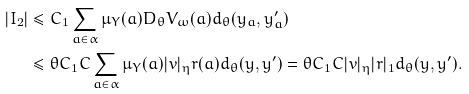<formula> <loc_0><loc_0><loc_500><loc_500>| I _ { 2 } | & \leq C _ { 1 } \sum _ { a \in \alpha } \mu _ { Y } ( a ) D _ { \theta } V _ { \omega } ( a ) d _ { \theta } ( y _ { a } , y _ { a } ^ { \prime } ) \\ & \leq \theta C _ { 1 } C \sum _ { a \in \alpha } \mu _ { Y } ( a ) | v | _ { \eta } r ( a ) d _ { \theta } ( y , y ^ { \prime } ) = \theta C _ { 1 } C | v | _ { \eta } | r | _ { 1 } d _ { \theta } ( y , y ^ { \prime } ) .</formula> 